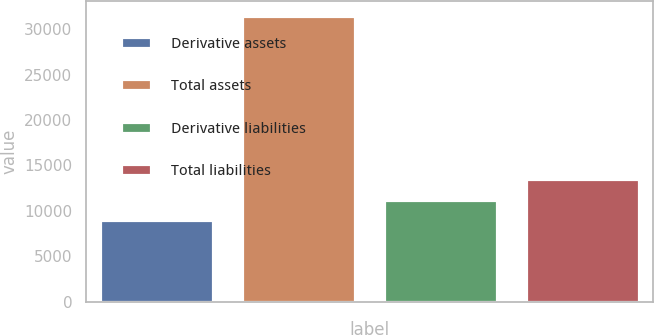<chart> <loc_0><loc_0><loc_500><loc_500><bar_chart><fcel>Derivative assets<fcel>Total assets<fcel>Derivative liabilities<fcel>Total liabilities<nl><fcel>8972<fcel>31470<fcel>11221.8<fcel>13471.6<nl></chart> 